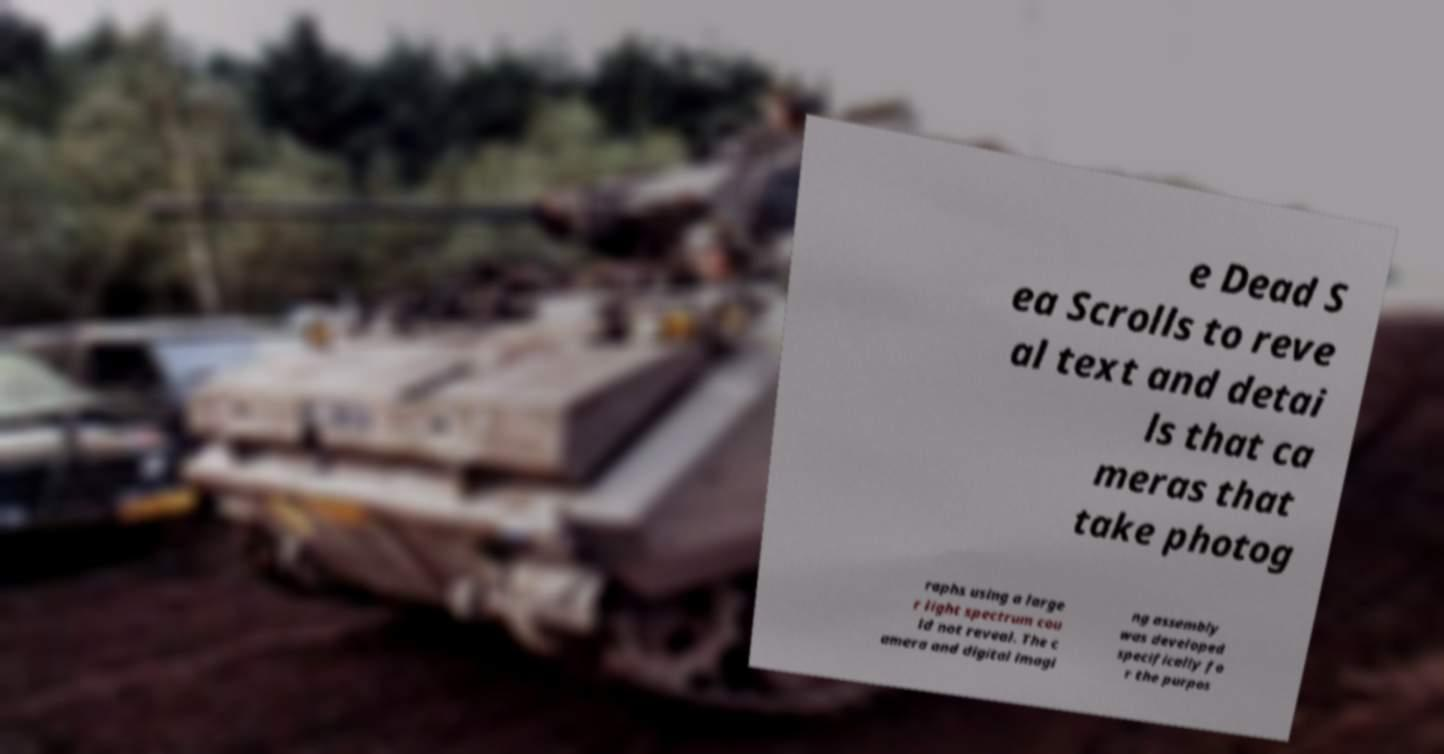Please read and relay the text visible in this image. What does it say? e Dead S ea Scrolls to reve al text and detai ls that ca meras that take photog raphs using a large r light spectrum cou ld not reveal. The c amera and digital imagi ng assembly was developed specifically fo r the purpos 